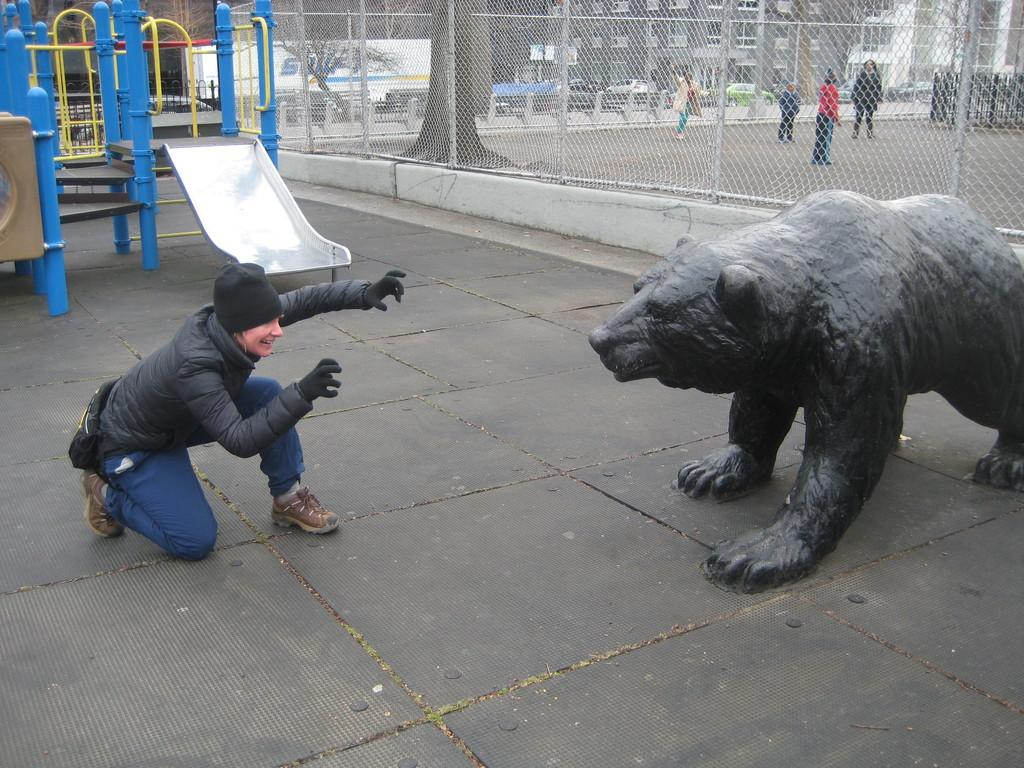How many people can be seen in the image? There are people in the image, but the exact number is not specified. What is the main feature in the image besides the people? There is a statue in the image. What type of structures are visible in the image? There are buildings in the image. What type of vegetation is present in the image? There are trees in the image. What type of transportation can be seen in the image? There are vehicles in the image. What type of barrier is present in the image? There is a fence in the image. What type of playground equipment is present in the image? There is a slide in the image. Where is the floor located in the image? There is no specific mention of a floor in the image; it is not a separate feature. What type of meeting is taking place in the image? There is no indication of a meeting taking place in the image. How many times does the statue shake in the image? The statue does not shake in the image; it is stationary. 